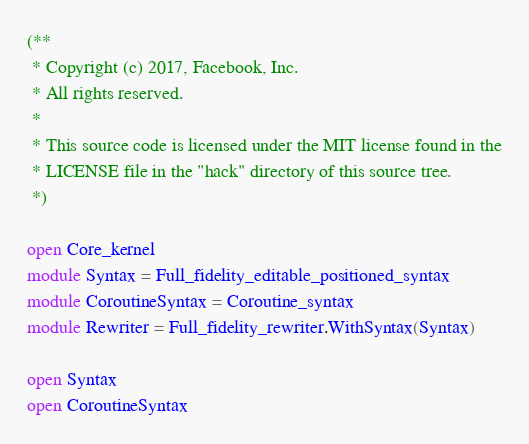Convert code to text. <code><loc_0><loc_0><loc_500><loc_500><_OCaml_>(**
 * Copyright (c) 2017, Facebook, Inc.
 * All rights reserved.
 *
 * This source code is licensed under the MIT license found in the
 * LICENSE file in the "hack" directory of this source tree.
 *)

open Core_kernel
module Syntax = Full_fidelity_editable_positioned_syntax
module CoroutineSyntax = Coroutine_syntax
module Rewriter = Full_fidelity_rewriter.WithSyntax(Syntax)

open Syntax
open CoroutineSyntax
</code> 